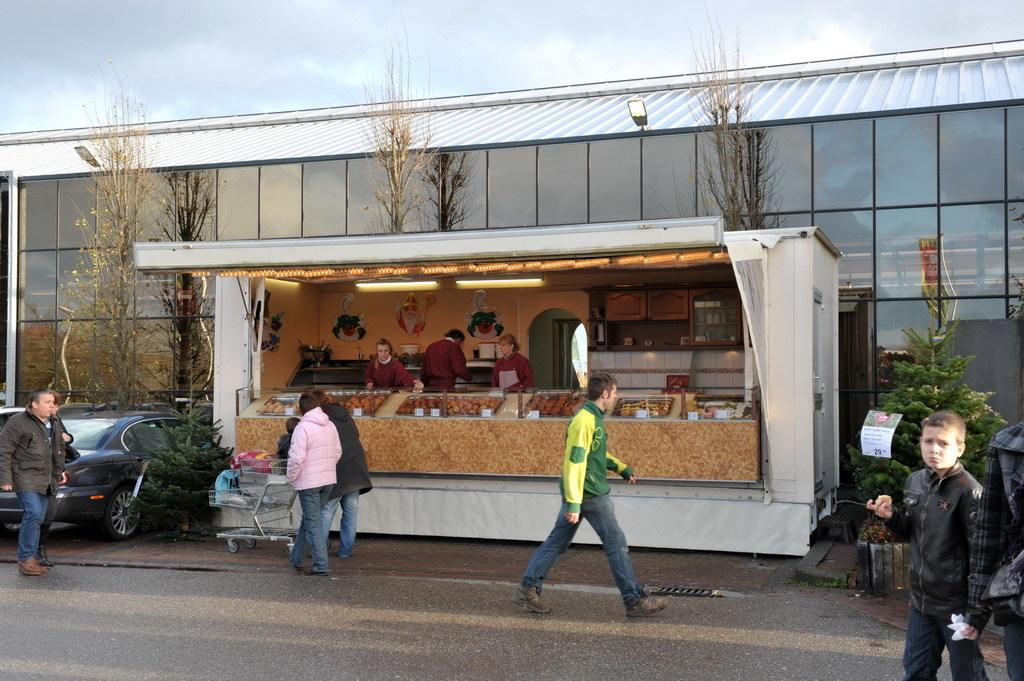What type of establishment is visible in the image? There is a shop present in the image. Where is the shop located in relation to other structures? The shop is in front of a building. What can be seen near the shop? There are vehicles parked by the side of the road. What is happening in front of the shop? People are walking in front of the shop. How many cows are grazing near the shop in the image? There are no cows present in the image; it features a shop, a building, parked vehicles, and people walking. 